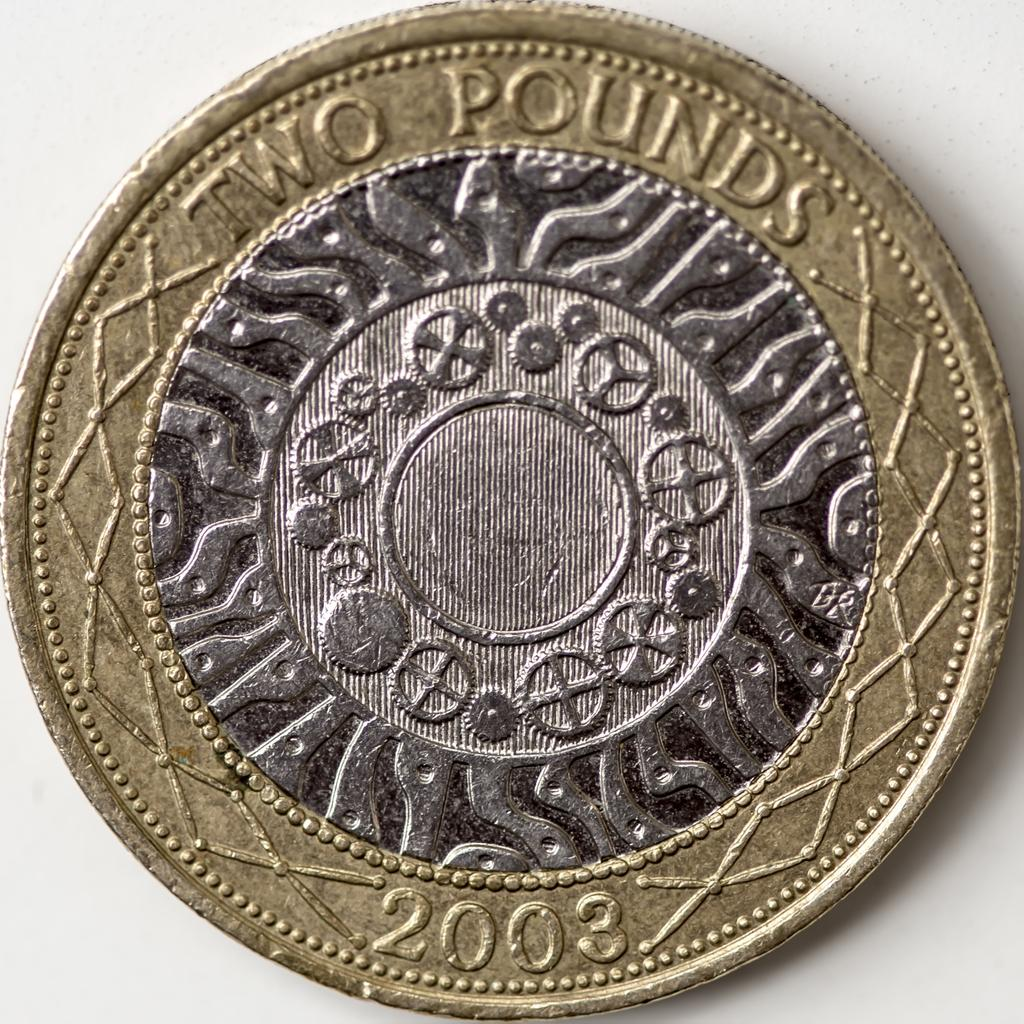<image>
Offer a succinct explanation of the picture presented. a 2003 two pound coin has several layers of metal color 